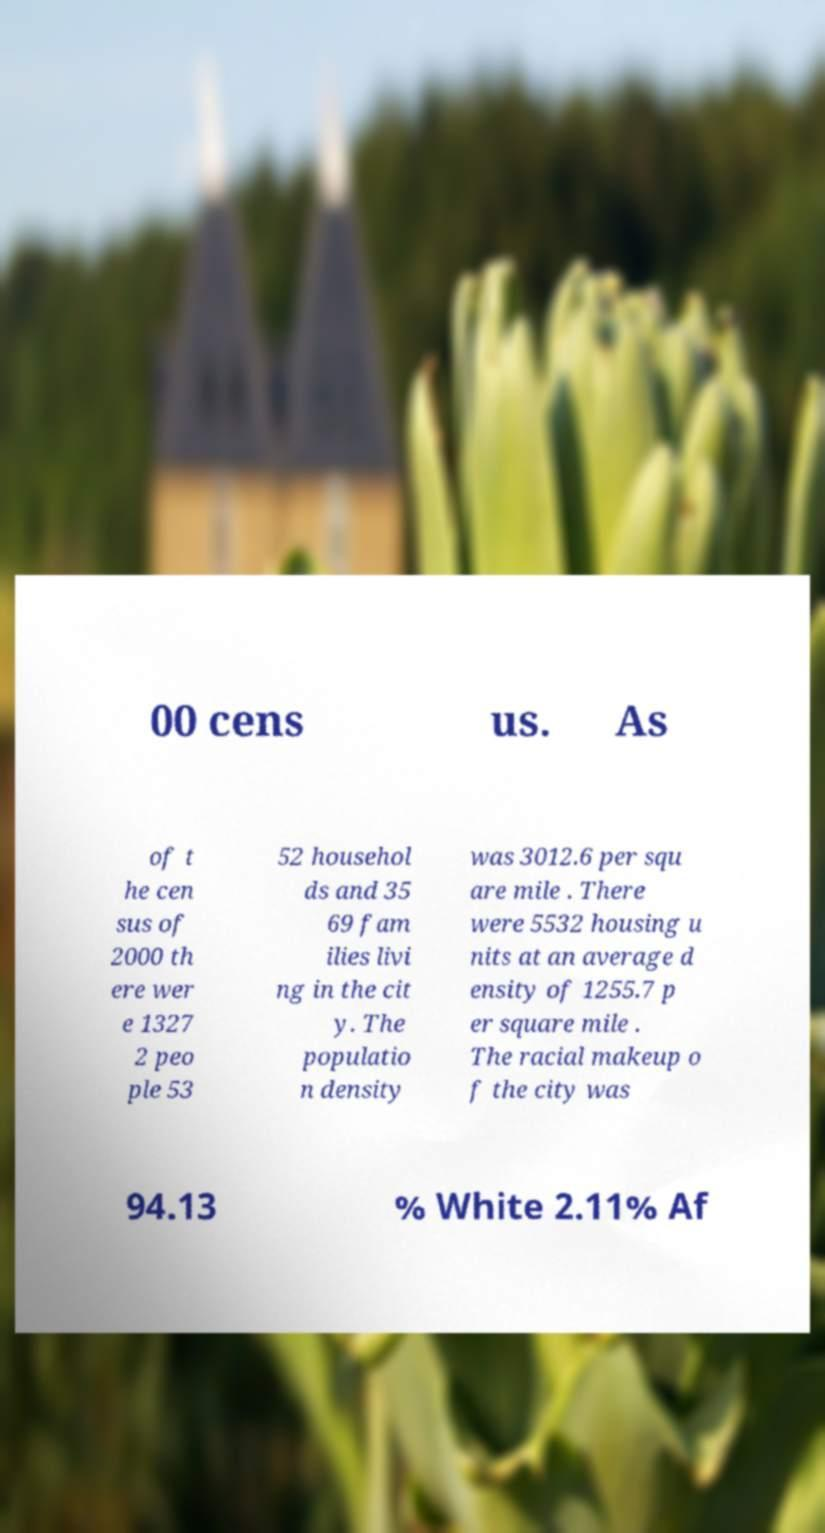For documentation purposes, I need the text within this image transcribed. Could you provide that? 00 cens us. As of t he cen sus of 2000 th ere wer e 1327 2 peo ple 53 52 househol ds and 35 69 fam ilies livi ng in the cit y. The populatio n density was 3012.6 per squ are mile . There were 5532 housing u nits at an average d ensity of 1255.7 p er square mile . The racial makeup o f the city was 94.13 % White 2.11% Af 